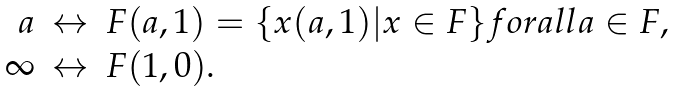<formula> <loc_0><loc_0><loc_500><loc_500>\begin{array} { r c l } a & \leftrightarrow & F ( a , 1 ) = \{ x ( a , 1 ) | x \in F \} f o r a l l a \in F , \\ \infty & \leftrightarrow & F ( 1 , 0 ) . \end{array}</formula> 